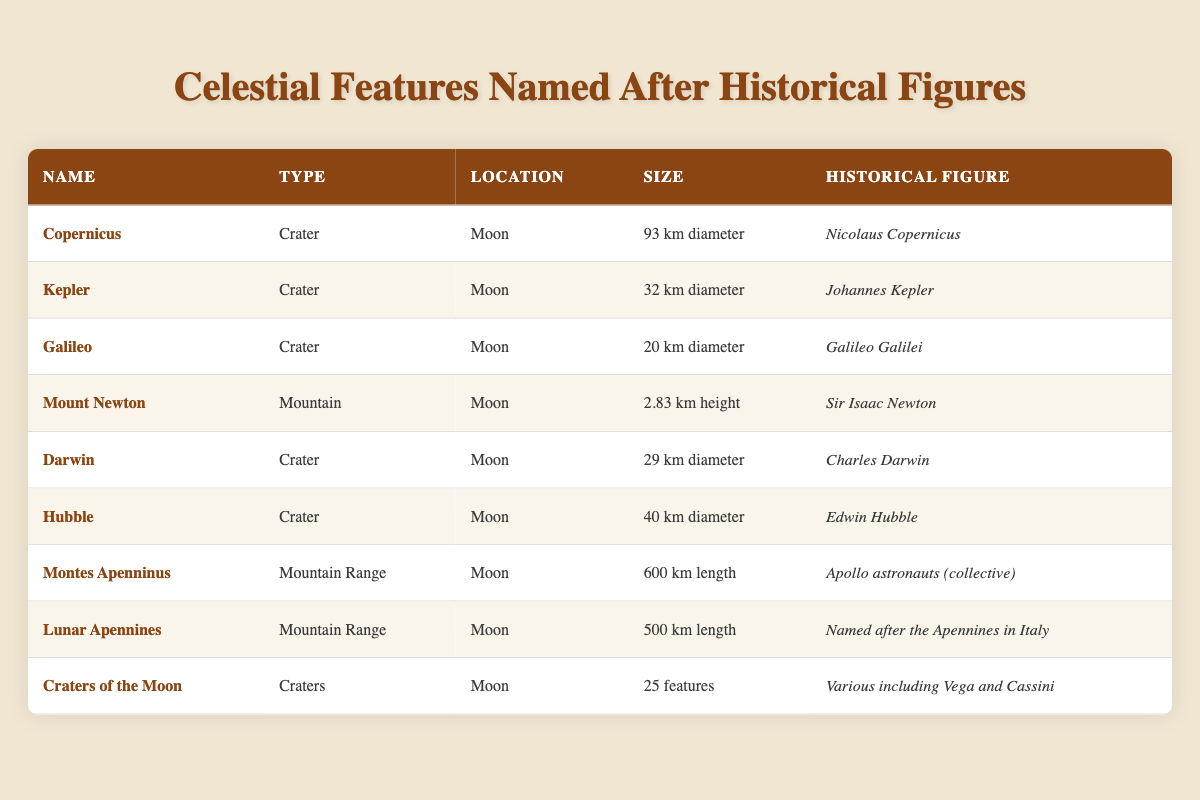What is the diameter of the Copernicus crater? The table lists the diameter of the Copernicus crater as 93 km in the corresponding row.
Answer: 93 km How many craters are named in the table? By counting the rows where the type is "Crater," we find that there are 5 craters listed: Copernicus, Kepler, Galileo, Darwin, and Hubble.
Answer: 5 Is Mount Newton a crater? The table indicates that Mount Newton is classified as a Mountain, not a crater, making this statement false.
Answer: No What is the combined diameter of the craters Kepler and Hubble? Kepler has a diameter of 32 km, and Hubble has a diameter of 40 km. Adding these together gives 32 km + 40 km = 72 km.
Answer: 72 km Which historical figure is associated with the largest mountain feature in the table? The Montes Apenninus is the longest mountain range at 600 km and is associated with Apollo astronauts (collective).
Answer: Apollo astronauts (collective) Are there any mountain ranges named in the table? Yes, the table explicitly lists two mountain ranges: Montes Apenninus and Lunar Apennines. Therefore, the answer is true.
Answer: Yes What is the total length of the mountain ranges listed in the table? The Montes Apenninus has a length of 600 km, and the Lunar Apennines has a length of 500 km. Adding these together gives 600 km + 500 km = 1100 km.
Answer: 1100 km Which crater has the smallest diameter? Looking through the diameter values, the Galileo crater has the smallest diameter at 20 km, which is less than the others.
Answer: 20 km Is the Craters of the Moon feature associated with a single historical figure? The table indicates that Craters of the Moon is attributed to various historical figures including Vega and Cassini, which means it is not associated with just one.
Answer: No 